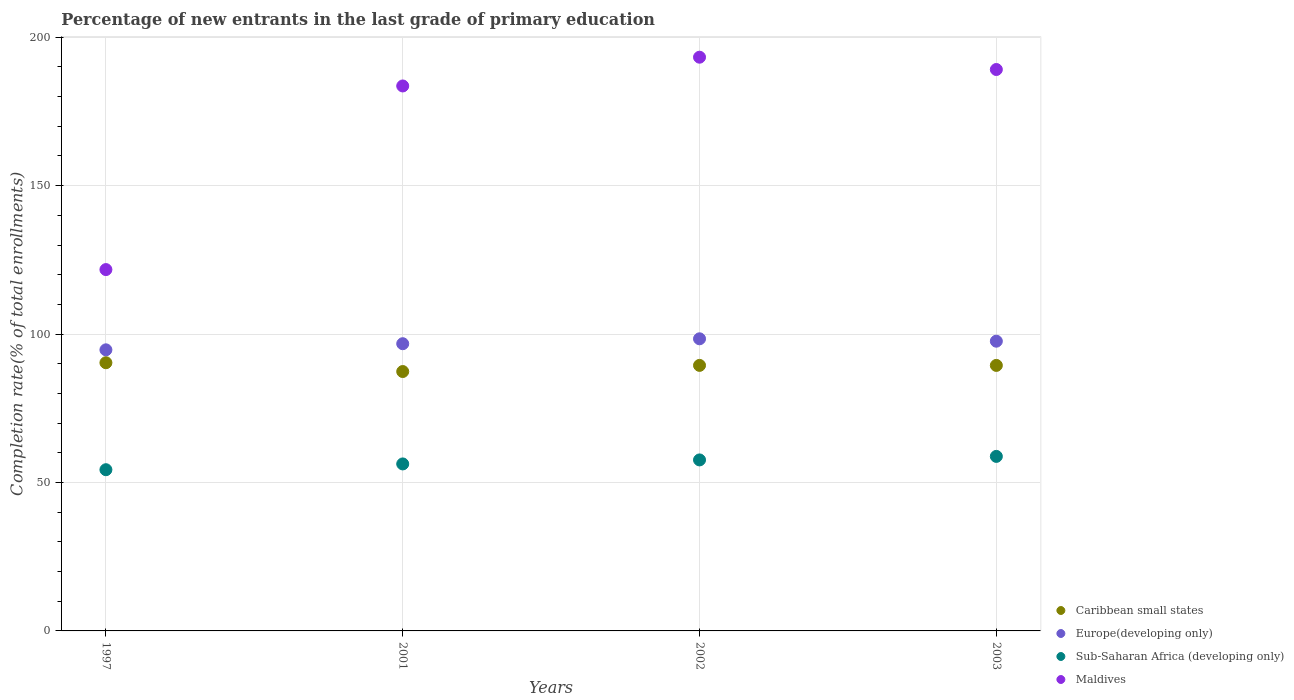How many different coloured dotlines are there?
Provide a short and direct response. 4. Is the number of dotlines equal to the number of legend labels?
Make the answer very short. Yes. What is the percentage of new entrants in Sub-Saharan Africa (developing only) in 2002?
Your answer should be compact. 57.6. Across all years, what is the maximum percentage of new entrants in Caribbean small states?
Offer a very short reply. 90.34. Across all years, what is the minimum percentage of new entrants in Sub-Saharan Africa (developing only)?
Your answer should be very brief. 54.31. In which year was the percentage of new entrants in Caribbean small states minimum?
Provide a short and direct response. 2001. What is the total percentage of new entrants in Caribbean small states in the graph?
Offer a terse response. 356.61. What is the difference between the percentage of new entrants in Caribbean small states in 2002 and that in 2003?
Offer a very short reply. 0.01. What is the difference between the percentage of new entrants in Caribbean small states in 2003 and the percentage of new entrants in Maldives in 2001?
Provide a succinct answer. -94.13. What is the average percentage of new entrants in Maldives per year?
Give a very brief answer. 171.92. In the year 2002, what is the difference between the percentage of new entrants in Europe(developing only) and percentage of new entrants in Caribbean small states?
Provide a succinct answer. 8.96. In how many years, is the percentage of new entrants in Europe(developing only) greater than 70 %?
Your response must be concise. 4. What is the ratio of the percentage of new entrants in Sub-Saharan Africa (developing only) in 1997 to that in 2002?
Offer a very short reply. 0.94. What is the difference between the highest and the second highest percentage of new entrants in Caribbean small states?
Provide a succinct answer. 0.9. What is the difference between the highest and the lowest percentage of new entrants in Maldives?
Your response must be concise. 71.54. In how many years, is the percentage of new entrants in Sub-Saharan Africa (developing only) greater than the average percentage of new entrants in Sub-Saharan Africa (developing only) taken over all years?
Offer a very short reply. 2. Is it the case that in every year, the sum of the percentage of new entrants in Caribbean small states and percentage of new entrants in Maldives  is greater than the percentage of new entrants in Sub-Saharan Africa (developing only)?
Offer a very short reply. Yes. Does the percentage of new entrants in Sub-Saharan Africa (developing only) monotonically increase over the years?
Provide a short and direct response. Yes. Is the percentage of new entrants in Europe(developing only) strictly less than the percentage of new entrants in Maldives over the years?
Offer a very short reply. Yes. How many dotlines are there?
Your answer should be very brief. 4. How many years are there in the graph?
Keep it short and to the point. 4. Where does the legend appear in the graph?
Offer a terse response. Bottom right. How are the legend labels stacked?
Your answer should be very brief. Vertical. What is the title of the graph?
Your answer should be compact. Percentage of new entrants in the last grade of primary education. Does "Tanzania" appear as one of the legend labels in the graph?
Offer a terse response. No. What is the label or title of the Y-axis?
Offer a very short reply. Completion rate(% of total enrollments). What is the Completion rate(% of total enrollments) of Caribbean small states in 1997?
Make the answer very short. 90.34. What is the Completion rate(% of total enrollments) in Europe(developing only) in 1997?
Your response must be concise. 94.69. What is the Completion rate(% of total enrollments) in Sub-Saharan Africa (developing only) in 1997?
Your answer should be very brief. 54.31. What is the Completion rate(% of total enrollments) of Maldives in 1997?
Provide a succinct answer. 121.72. What is the Completion rate(% of total enrollments) of Caribbean small states in 2001?
Your answer should be compact. 87.38. What is the Completion rate(% of total enrollments) in Europe(developing only) in 2001?
Offer a very short reply. 96.75. What is the Completion rate(% of total enrollments) of Sub-Saharan Africa (developing only) in 2001?
Provide a short and direct response. 56.25. What is the Completion rate(% of total enrollments) in Maldives in 2001?
Your answer should be compact. 183.57. What is the Completion rate(% of total enrollments) of Caribbean small states in 2002?
Your response must be concise. 89.45. What is the Completion rate(% of total enrollments) of Europe(developing only) in 2002?
Ensure brevity in your answer.  98.4. What is the Completion rate(% of total enrollments) in Sub-Saharan Africa (developing only) in 2002?
Offer a very short reply. 57.6. What is the Completion rate(% of total enrollments) of Maldives in 2002?
Provide a short and direct response. 193.26. What is the Completion rate(% of total enrollments) in Caribbean small states in 2003?
Keep it short and to the point. 89.44. What is the Completion rate(% of total enrollments) in Europe(developing only) in 2003?
Your response must be concise. 97.6. What is the Completion rate(% of total enrollments) in Sub-Saharan Africa (developing only) in 2003?
Your response must be concise. 58.79. What is the Completion rate(% of total enrollments) in Maldives in 2003?
Provide a short and direct response. 189.12. Across all years, what is the maximum Completion rate(% of total enrollments) in Caribbean small states?
Provide a succinct answer. 90.34. Across all years, what is the maximum Completion rate(% of total enrollments) in Europe(developing only)?
Offer a terse response. 98.4. Across all years, what is the maximum Completion rate(% of total enrollments) of Sub-Saharan Africa (developing only)?
Make the answer very short. 58.79. Across all years, what is the maximum Completion rate(% of total enrollments) of Maldives?
Your answer should be compact. 193.26. Across all years, what is the minimum Completion rate(% of total enrollments) in Caribbean small states?
Make the answer very short. 87.38. Across all years, what is the minimum Completion rate(% of total enrollments) in Europe(developing only)?
Give a very brief answer. 94.69. Across all years, what is the minimum Completion rate(% of total enrollments) of Sub-Saharan Africa (developing only)?
Offer a very short reply. 54.31. Across all years, what is the minimum Completion rate(% of total enrollments) in Maldives?
Your answer should be compact. 121.72. What is the total Completion rate(% of total enrollments) of Caribbean small states in the graph?
Your answer should be very brief. 356.61. What is the total Completion rate(% of total enrollments) of Europe(developing only) in the graph?
Offer a very short reply. 387.44. What is the total Completion rate(% of total enrollments) of Sub-Saharan Africa (developing only) in the graph?
Your answer should be compact. 226.95. What is the total Completion rate(% of total enrollments) of Maldives in the graph?
Provide a short and direct response. 687.68. What is the difference between the Completion rate(% of total enrollments) of Caribbean small states in 1997 and that in 2001?
Your answer should be very brief. 2.97. What is the difference between the Completion rate(% of total enrollments) of Europe(developing only) in 1997 and that in 2001?
Provide a succinct answer. -2.06. What is the difference between the Completion rate(% of total enrollments) of Sub-Saharan Africa (developing only) in 1997 and that in 2001?
Provide a succinct answer. -1.95. What is the difference between the Completion rate(% of total enrollments) in Maldives in 1997 and that in 2001?
Offer a very short reply. -61.85. What is the difference between the Completion rate(% of total enrollments) of Caribbean small states in 1997 and that in 2002?
Offer a very short reply. 0.9. What is the difference between the Completion rate(% of total enrollments) in Europe(developing only) in 1997 and that in 2002?
Your answer should be very brief. -3.72. What is the difference between the Completion rate(% of total enrollments) of Sub-Saharan Africa (developing only) in 1997 and that in 2002?
Ensure brevity in your answer.  -3.3. What is the difference between the Completion rate(% of total enrollments) in Maldives in 1997 and that in 2002?
Your answer should be very brief. -71.54. What is the difference between the Completion rate(% of total enrollments) of Caribbean small states in 1997 and that in 2003?
Offer a very short reply. 0.9. What is the difference between the Completion rate(% of total enrollments) in Europe(developing only) in 1997 and that in 2003?
Provide a short and direct response. -2.91. What is the difference between the Completion rate(% of total enrollments) in Sub-Saharan Africa (developing only) in 1997 and that in 2003?
Your response must be concise. -4.49. What is the difference between the Completion rate(% of total enrollments) in Maldives in 1997 and that in 2003?
Offer a very short reply. -67.4. What is the difference between the Completion rate(% of total enrollments) of Caribbean small states in 2001 and that in 2002?
Your response must be concise. -2.07. What is the difference between the Completion rate(% of total enrollments) of Europe(developing only) in 2001 and that in 2002?
Provide a succinct answer. -1.66. What is the difference between the Completion rate(% of total enrollments) of Sub-Saharan Africa (developing only) in 2001 and that in 2002?
Ensure brevity in your answer.  -1.35. What is the difference between the Completion rate(% of total enrollments) in Maldives in 2001 and that in 2002?
Ensure brevity in your answer.  -9.69. What is the difference between the Completion rate(% of total enrollments) of Caribbean small states in 2001 and that in 2003?
Make the answer very short. -2.06. What is the difference between the Completion rate(% of total enrollments) in Europe(developing only) in 2001 and that in 2003?
Offer a very short reply. -0.85. What is the difference between the Completion rate(% of total enrollments) in Sub-Saharan Africa (developing only) in 2001 and that in 2003?
Offer a very short reply. -2.54. What is the difference between the Completion rate(% of total enrollments) of Maldives in 2001 and that in 2003?
Provide a short and direct response. -5.54. What is the difference between the Completion rate(% of total enrollments) of Caribbean small states in 2002 and that in 2003?
Ensure brevity in your answer.  0.01. What is the difference between the Completion rate(% of total enrollments) of Europe(developing only) in 2002 and that in 2003?
Provide a succinct answer. 0.8. What is the difference between the Completion rate(% of total enrollments) of Sub-Saharan Africa (developing only) in 2002 and that in 2003?
Provide a succinct answer. -1.19. What is the difference between the Completion rate(% of total enrollments) of Maldives in 2002 and that in 2003?
Give a very brief answer. 4.15. What is the difference between the Completion rate(% of total enrollments) in Caribbean small states in 1997 and the Completion rate(% of total enrollments) in Europe(developing only) in 2001?
Ensure brevity in your answer.  -6.4. What is the difference between the Completion rate(% of total enrollments) of Caribbean small states in 1997 and the Completion rate(% of total enrollments) of Sub-Saharan Africa (developing only) in 2001?
Your response must be concise. 34.09. What is the difference between the Completion rate(% of total enrollments) in Caribbean small states in 1997 and the Completion rate(% of total enrollments) in Maldives in 2001?
Offer a terse response. -93.23. What is the difference between the Completion rate(% of total enrollments) of Europe(developing only) in 1997 and the Completion rate(% of total enrollments) of Sub-Saharan Africa (developing only) in 2001?
Your answer should be compact. 38.44. What is the difference between the Completion rate(% of total enrollments) of Europe(developing only) in 1997 and the Completion rate(% of total enrollments) of Maldives in 2001?
Give a very brief answer. -88.88. What is the difference between the Completion rate(% of total enrollments) in Sub-Saharan Africa (developing only) in 1997 and the Completion rate(% of total enrollments) in Maldives in 2001?
Your answer should be very brief. -129.27. What is the difference between the Completion rate(% of total enrollments) in Caribbean small states in 1997 and the Completion rate(% of total enrollments) in Europe(developing only) in 2002?
Provide a succinct answer. -8.06. What is the difference between the Completion rate(% of total enrollments) of Caribbean small states in 1997 and the Completion rate(% of total enrollments) of Sub-Saharan Africa (developing only) in 2002?
Ensure brevity in your answer.  32.74. What is the difference between the Completion rate(% of total enrollments) in Caribbean small states in 1997 and the Completion rate(% of total enrollments) in Maldives in 2002?
Provide a succinct answer. -102.92. What is the difference between the Completion rate(% of total enrollments) in Europe(developing only) in 1997 and the Completion rate(% of total enrollments) in Sub-Saharan Africa (developing only) in 2002?
Ensure brevity in your answer.  37.09. What is the difference between the Completion rate(% of total enrollments) of Europe(developing only) in 1997 and the Completion rate(% of total enrollments) of Maldives in 2002?
Offer a very short reply. -98.57. What is the difference between the Completion rate(% of total enrollments) of Sub-Saharan Africa (developing only) in 1997 and the Completion rate(% of total enrollments) of Maldives in 2002?
Make the answer very short. -138.96. What is the difference between the Completion rate(% of total enrollments) of Caribbean small states in 1997 and the Completion rate(% of total enrollments) of Europe(developing only) in 2003?
Ensure brevity in your answer.  -7.26. What is the difference between the Completion rate(% of total enrollments) of Caribbean small states in 1997 and the Completion rate(% of total enrollments) of Sub-Saharan Africa (developing only) in 2003?
Provide a succinct answer. 31.55. What is the difference between the Completion rate(% of total enrollments) in Caribbean small states in 1997 and the Completion rate(% of total enrollments) in Maldives in 2003?
Your answer should be compact. -98.77. What is the difference between the Completion rate(% of total enrollments) of Europe(developing only) in 1997 and the Completion rate(% of total enrollments) of Sub-Saharan Africa (developing only) in 2003?
Offer a terse response. 35.9. What is the difference between the Completion rate(% of total enrollments) in Europe(developing only) in 1997 and the Completion rate(% of total enrollments) in Maldives in 2003?
Give a very brief answer. -94.43. What is the difference between the Completion rate(% of total enrollments) of Sub-Saharan Africa (developing only) in 1997 and the Completion rate(% of total enrollments) of Maldives in 2003?
Provide a short and direct response. -134.81. What is the difference between the Completion rate(% of total enrollments) of Caribbean small states in 2001 and the Completion rate(% of total enrollments) of Europe(developing only) in 2002?
Your response must be concise. -11.03. What is the difference between the Completion rate(% of total enrollments) of Caribbean small states in 2001 and the Completion rate(% of total enrollments) of Sub-Saharan Africa (developing only) in 2002?
Your answer should be very brief. 29.77. What is the difference between the Completion rate(% of total enrollments) of Caribbean small states in 2001 and the Completion rate(% of total enrollments) of Maldives in 2002?
Provide a short and direct response. -105.89. What is the difference between the Completion rate(% of total enrollments) of Europe(developing only) in 2001 and the Completion rate(% of total enrollments) of Sub-Saharan Africa (developing only) in 2002?
Provide a short and direct response. 39.15. What is the difference between the Completion rate(% of total enrollments) of Europe(developing only) in 2001 and the Completion rate(% of total enrollments) of Maldives in 2002?
Your response must be concise. -96.51. What is the difference between the Completion rate(% of total enrollments) in Sub-Saharan Africa (developing only) in 2001 and the Completion rate(% of total enrollments) in Maldives in 2002?
Your answer should be compact. -137.01. What is the difference between the Completion rate(% of total enrollments) in Caribbean small states in 2001 and the Completion rate(% of total enrollments) in Europe(developing only) in 2003?
Provide a succinct answer. -10.22. What is the difference between the Completion rate(% of total enrollments) of Caribbean small states in 2001 and the Completion rate(% of total enrollments) of Sub-Saharan Africa (developing only) in 2003?
Keep it short and to the point. 28.59. What is the difference between the Completion rate(% of total enrollments) in Caribbean small states in 2001 and the Completion rate(% of total enrollments) in Maldives in 2003?
Give a very brief answer. -101.74. What is the difference between the Completion rate(% of total enrollments) of Europe(developing only) in 2001 and the Completion rate(% of total enrollments) of Sub-Saharan Africa (developing only) in 2003?
Your answer should be compact. 37.96. What is the difference between the Completion rate(% of total enrollments) in Europe(developing only) in 2001 and the Completion rate(% of total enrollments) in Maldives in 2003?
Your answer should be compact. -92.37. What is the difference between the Completion rate(% of total enrollments) in Sub-Saharan Africa (developing only) in 2001 and the Completion rate(% of total enrollments) in Maldives in 2003?
Make the answer very short. -132.86. What is the difference between the Completion rate(% of total enrollments) of Caribbean small states in 2002 and the Completion rate(% of total enrollments) of Europe(developing only) in 2003?
Offer a terse response. -8.15. What is the difference between the Completion rate(% of total enrollments) of Caribbean small states in 2002 and the Completion rate(% of total enrollments) of Sub-Saharan Africa (developing only) in 2003?
Provide a short and direct response. 30.65. What is the difference between the Completion rate(% of total enrollments) of Caribbean small states in 2002 and the Completion rate(% of total enrollments) of Maldives in 2003?
Make the answer very short. -99.67. What is the difference between the Completion rate(% of total enrollments) in Europe(developing only) in 2002 and the Completion rate(% of total enrollments) in Sub-Saharan Africa (developing only) in 2003?
Provide a succinct answer. 39.61. What is the difference between the Completion rate(% of total enrollments) of Europe(developing only) in 2002 and the Completion rate(% of total enrollments) of Maldives in 2003?
Keep it short and to the point. -90.71. What is the difference between the Completion rate(% of total enrollments) in Sub-Saharan Africa (developing only) in 2002 and the Completion rate(% of total enrollments) in Maldives in 2003?
Offer a very short reply. -131.52. What is the average Completion rate(% of total enrollments) in Caribbean small states per year?
Your answer should be compact. 89.15. What is the average Completion rate(% of total enrollments) in Europe(developing only) per year?
Keep it short and to the point. 96.86. What is the average Completion rate(% of total enrollments) of Sub-Saharan Africa (developing only) per year?
Keep it short and to the point. 56.74. What is the average Completion rate(% of total enrollments) of Maldives per year?
Offer a terse response. 171.92. In the year 1997, what is the difference between the Completion rate(% of total enrollments) of Caribbean small states and Completion rate(% of total enrollments) of Europe(developing only)?
Your response must be concise. -4.35. In the year 1997, what is the difference between the Completion rate(% of total enrollments) of Caribbean small states and Completion rate(% of total enrollments) of Sub-Saharan Africa (developing only)?
Offer a terse response. 36.04. In the year 1997, what is the difference between the Completion rate(% of total enrollments) in Caribbean small states and Completion rate(% of total enrollments) in Maldives?
Make the answer very short. -31.38. In the year 1997, what is the difference between the Completion rate(% of total enrollments) in Europe(developing only) and Completion rate(% of total enrollments) in Sub-Saharan Africa (developing only)?
Make the answer very short. 40.38. In the year 1997, what is the difference between the Completion rate(% of total enrollments) of Europe(developing only) and Completion rate(% of total enrollments) of Maldives?
Offer a terse response. -27.03. In the year 1997, what is the difference between the Completion rate(% of total enrollments) in Sub-Saharan Africa (developing only) and Completion rate(% of total enrollments) in Maldives?
Ensure brevity in your answer.  -67.41. In the year 2001, what is the difference between the Completion rate(% of total enrollments) of Caribbean small states and Completion rate(% of total enrollments) of Europe(developing only)?
Provide a succinct answer. -9.37. In the year 2001, what is the difference between the Completion rate(% of total enrollments) in Caribbean small states and Completion rate(% of total enrollments) in Sub-Saharan Africa (developing only)?
Provide a short and direct response. 31.12. In the year 2001, what is the difference between the Completion rate(% of total enrollments) in Caribbean small states and Completion rate(% of total enrollments) in Maldives?
Keep it short and to the point. -96.2. In the year 2001, what is the difference between the Completion rate(% of total enrollments) in Europe(developing only) and Completion rate(% of total enrollments) in Sub-Saharan Africa (developing only)?
Your response must be concise. 40.5. In the year 2001, what is the difference between the Completion rate(% of total enrollments) of Europe(developing only) and Completion rate(% of total enrollments) of Maldives?
Offer a terse response. -86.83. In the year 2001, what is the difference between the Completion rate(% of total enrollments) in Sub-Saharan Africa (developing only) and Completion rate(% of total enrollments) in Maldives?
Offer a terse response. -127.32. In the year 2002, what is the difference between the Completion rate(% of total enrollments) of Caribbean small states and Completion rate(% of total enrollments) of Europe(developing only)?
Ensure brevity in your answer.  -8.96. In the year 2002, what is the difference between the Completion rate(% of total enrollments) of Caribbean small states and Completion rate(% of total enrollments) of Sub-Saharan Africa (developing only)?
Provide a short and direct response. 31.84. In the year 2002, what is the difference between the Completion rate(% of total enrollments) in Caribbean small states and Completion rate(% of total enrollments) in Maldives?
Keep it short and to the point. -103.82. In the year 2002, what is the difference between the Completion rate(% of total enrollments) of Europe(developing only) and Completion rate(% of total enrollments) of Sub-Saharan Africa (developing only)?
Make the answer very short. 40.8. In the year 2002, what is the difference between the Completion rate(% of total enrollments) of Europe(developing only) and Completion rate(% of total enrollments) of Maldives?
Your answer should be compact. -94.86. In the year 2002, what is the difference between the Completion rate(% of total enrollments) of Sub-Saharan Africa (developing only) and Completion rate(% of total enrollments) of Maldives?
Make the answer very short. -135.66. In the year 2003, what is the difference between the Completion rate(% of total enrollments) of Caribbean small states and Completion rate(% of total enrollments) of Europe(developing only)?
Your answer should be compact. -8.16. In the year 2003, what is the difference between the Completion rate(% of total enrollments) of Caribbean small states and Completion rate(% of total enrollments) of Sub-Saharan Africa (developing only)?
Offer a terse response. 30.65. In the year 2003, what is the difference between the Completion rate(% of total enrollments) of Caribbean small states and Completion rate(% of total enrollments) of Maldives?
Provide a short and direct response. -99.68. In the year 2003, what is the difference between the Completion rate(% of total enrollments) in Europe(developing only) and Completion rate(% of total enrollments) in Sub-Saharan Africa (developing only)?
Provide a short and direct response. 38.81. In the year 2003, what is the difference between the Completion rate(% of total enrollments) of Europe(developing only) and Completion rate(% of total enrollments) of Maldives?
Your answer should be compact. -91.52. In the year 2003, what is the difference between the Completion rate(% of total enrollments) of Sub-Saharan Africa (developing only) and Completion rate(% of total enrollments) of Maldives?
Offer a very short reply. -130.33. What is the ratio of the Completion rate(% of total enrollments) in Caribbean small states in 1997 to that in 2001?
Give a very brief answer. 1.03. What is the ratio of the Completion rate(% of total enrollments) of Europe(developing only) in 1997 to that in 2001?
Make the answer very short. 0.98. What is the ratio of the Completion rate(% of total enrollments) in Sub-Saharan Africa (developing only) in 1997 to that in 2001?
Keep it short and to the point. 0.97. What is the ratio of the Completion rate(% of total enrollments) of Maldives in 1997 to that in 2001?
Your answer should be very brief. 0.66. What is the ratio of the Completion rate(% of total enrollments) in Caribbean small states in 1997 to that in 2002?
Provide a short and direct response. 1.01. What is the ratio of the Completion rate(% of total enrollments) in Europe(developing only) in 1997 to that in 2002?
Your answer should be compact. 0.96. What is the ratio of the Completion rate(% of total enrollments) of Sub-Saharan Africa (developing only) in 1997 to that in 2002?
Provide a short and direct response. 0.94. What is the ratio of the Completion rate(% of total enrollments) of Maldives in 1997 to that in 2002?
Your response must be concise. 0.63. What is the ratio of the Completion rate(% of total enrollments) in Europe(developing only) in 1997 to that in 2003?
Your response must be concise. 0.97. What is the ratio of the Completion rate(% of total enrollments) of Sub-Saharan Africa (developing only) in 1997 to that in 2003?
Your response must be concise. 0.92. What is the ratio of the Completion rate(% of total enrollments) of Maldives in 1997 to that in 2003?
Make the answer very short. 0.64. What is the ratio of the Completion rate(% of total enrollments) in Caribbean small states in 2001 to that in 2002?
Your answer should be very brief. 0.98. What is the ratio of the Completion rate(% of total enrollments) in Europe(developing only) in 2001 to that in 2002?
Give a very brief answer. 0.98. What is the ratio of the Completion rate(% of total enrollments) in Sub-Saharan Africa (developing only) in 2001 to that in 2002?
Keep it short and to the point. 0.98. What is the ratio of the Completion rate(% of total enrollments) of Maldives in 2001 to that in 2002?
Keep it short and to the point. 0.95. What is the ratio of the Completion rate(% of total enrollments) of Caribbean small states in 2001 to that in 2003?
Keep it short and to the point. 0.98. What is the ratio of the Completion rate(% of total enrollments) in Sub-Saharan Africa (developing only) in 2001 to that in 2003?
Your response must be concise. 0.96. What is the ratio of the Completion rate(% of total enrollments) of Maldives in 2001 to that in 2003?
Your answer should be very brief. 0.97. What is the ratio of the Completion rate(% of total enrollments) in Europe(developing only) in 2002 to that in 2003?
Make the answer very short. 1.01. What is the ratio of the Completion rate(% of total enrollments) in Sub-Saharan Africa (developing only) in 2002 to that in 2003?
Offer a very short reply. 0.98. What is the ratio of the Completion rate(% of total enrollments) of Maldives in 2002 to that in 2003?
Make the answer very short. 1.02. What is the difference between the highest and the second highest Completion rate(% of total enrollments) in Caribbean small states?
Your answer should be very brief. 0.9. What is the difference between the highest and the second highest Completion rate(% of total enrollments) in Europe(developing only)?
Your response must be concise. 0.8. What is the difference between the highest and the second highest Completion rate(% of total enrollments) of Sub-Saharan Africa (developing only)?
Offer a terse response. 1.19. What is the difference between the highest and the second highest Completion rate(% of total enrollments) of Maldives?
Your answer should be very brief. 4.15. What is the difference between the highest and the lowest Completion rate(% of total enrollments) of Caribbean small states?
Provide a succinct answer. 2.97. What is the difference between the highest and the lowest Completion rate(% of total enrollments) of Europe(developing only)?
Your response must be concise. 3.72. What is the difference between the highest and the lowest Completion rate(% of total enrollments) of Sub-Saharan Africa (developing only)?
Ensure brevity in your answer.  4.49. What is the difference between the highest and the lowest Completion rate(% of total enrollments) in Maldives?
Your answer should be compact. 71.54. 